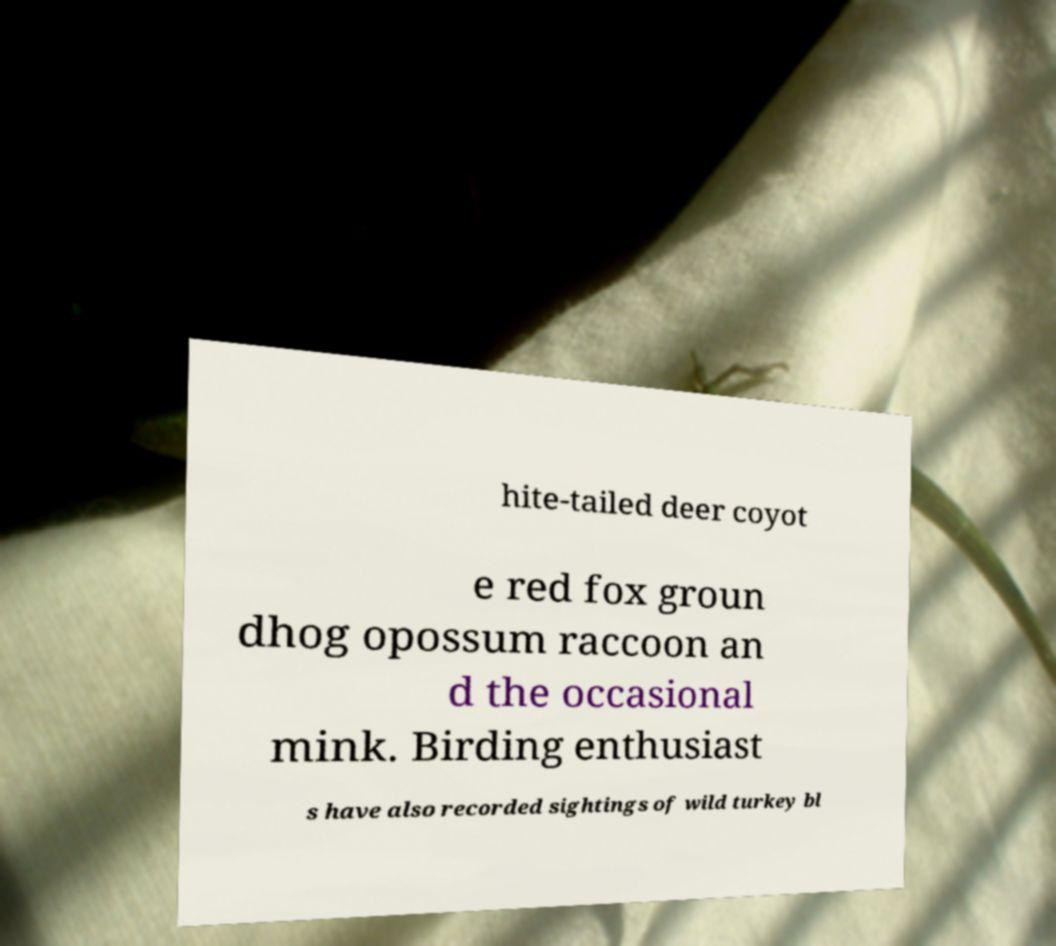There's text embedded in this image that I need extracted. Can you transcribe it verbatim? hite-tailed deer coyot e red fox groun dhog opossum raccoon an d the occasional mink. Birding enthusiast s have also recorded sightings of wild turkey bl 